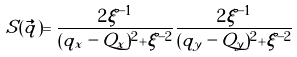Convert formula to latex. <formula><loc_0><loc_0><loc_500><loc_500>S ( { \vec { q } } ) = \frac { 2 \xi ^ { - 1 } } { ( q _ { x } - Q _ { x } ) ^ { 2 } + \xi ^ { - 2 } } \frac { 2 \xi ^ { - 1 } } { ( q _ { y } - Q _ { y } ) ^ { 2 } + \xi ^ { - 2 } }</formula> 